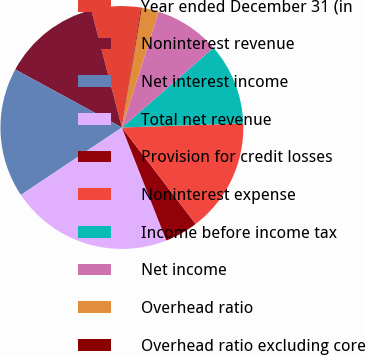Convert chart to OTSL. <chart><loc_0><loc_0><loc_500><loc_500><pie_chart><fcel>Year ended December 31 (in<fcel>Noninterest revenue<fcel>Net interest income<fcel>Total net revenue<fcel>Provision for credit losses<fcel>Noninterest expense<fcel>Income before income tax<fcel>Net income<fcel>Overhead ratio<fcel>Overhead ratio excluding core<nl><fcel>6.56%<fcel>13.01%<fcel>17.3%<fcel>21.59%<fcel>4.42%<fcel>15.15%<fcel>10.86%<fcel>8.71%<fcel>2.27%<fcel>0.12%<nl></chart> 